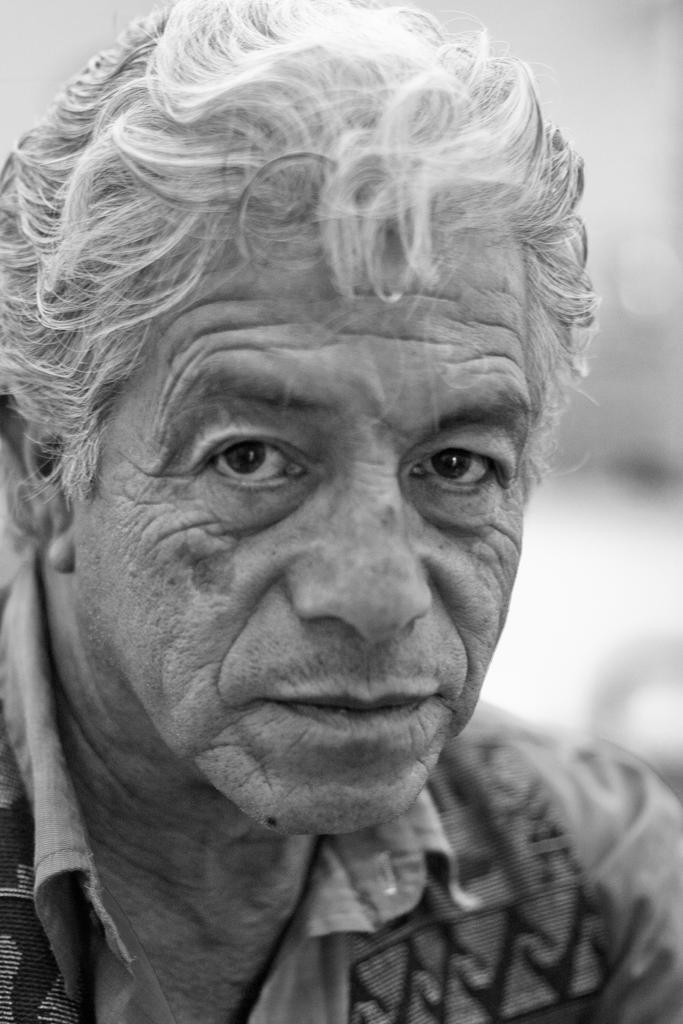Please provide a concise description of this image. In this image we can see the black and white picture of a man. 